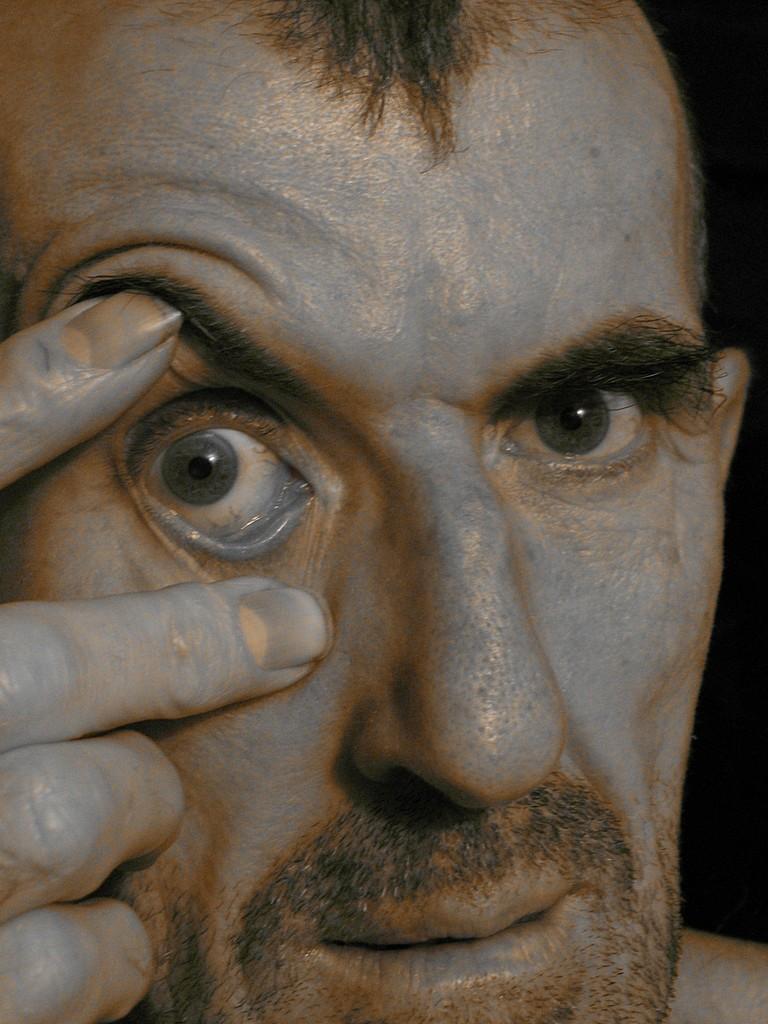Describe this image in one or two sentences. In this picture we can see a man face and behind the man there is a dark background. 